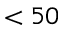Convert formula to latex. <formula><loc_0><loc_0><loc_500><loc_500>< 5 0</formula> 